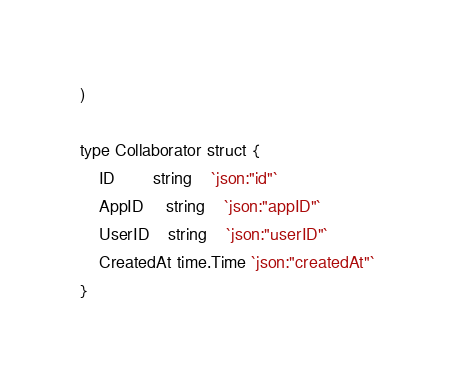<code> <loc_0><loc_0><loc_500><loc_500><_Go_>)

type Collaborator struct {
	ID        string    `json:"id"`
	AppID     string    `json:"appID"`
	UserID    string    `json:"userID"`
	CreatedAt time.Time `json:"createdAt"`
}
</code> 